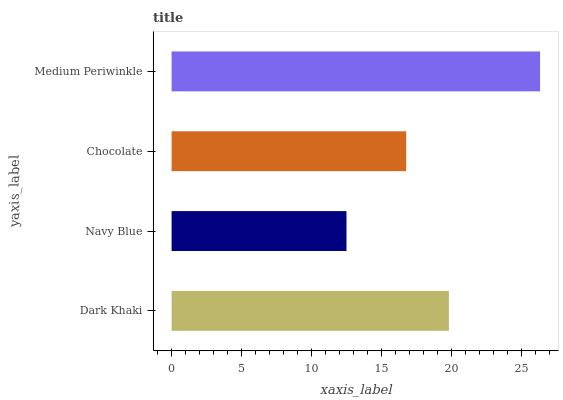Is Navy Blue the minimum?
Answer yes or no. Yes. Is Medium Periwinkle the maximum?
Answer yes or no. Yes. Is Chocolate the minimum?
Answer yes or no. No. Is Chocolate the maximum?
Answer yes or no. No. Is Chocolate greater than Navy Blue?
Answer yes or no. Yes. Is Navy Blue less than Chocolate?
Answer yes or no. Yes. Is Navy Blue greater than Chocolate?
Answer yes or no. No. Is Chocolate less than Navy Blue?
Answer yes or no. No. Is Dark Khaki the high median?
Answer yes or no. Yes. Is Chocolate the low median?
Answer yes or no. Yes. Is Navy Blue the high median?
Answer yes or no. No. Is Dark Khaki the low median?
Answer yes or no. No. 